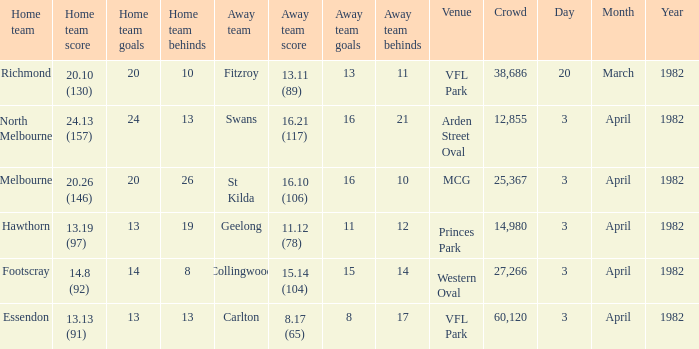12 (78), what was the date of the event? 3 April 1982. 